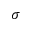<formula> <loc_0><loc_0><loc_500><loc_500>\sigma</formula> 